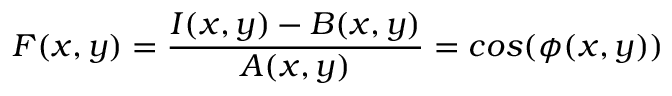Convert formula to latex. <formula><loc_0><loc_0><loc_500><loc_500>F ( x , y ) = \frac { I ( x , y ) - B ( x , y ) } { A ( x , y ) } = \cos ( { \phi } ( x , y ) )</formula> 